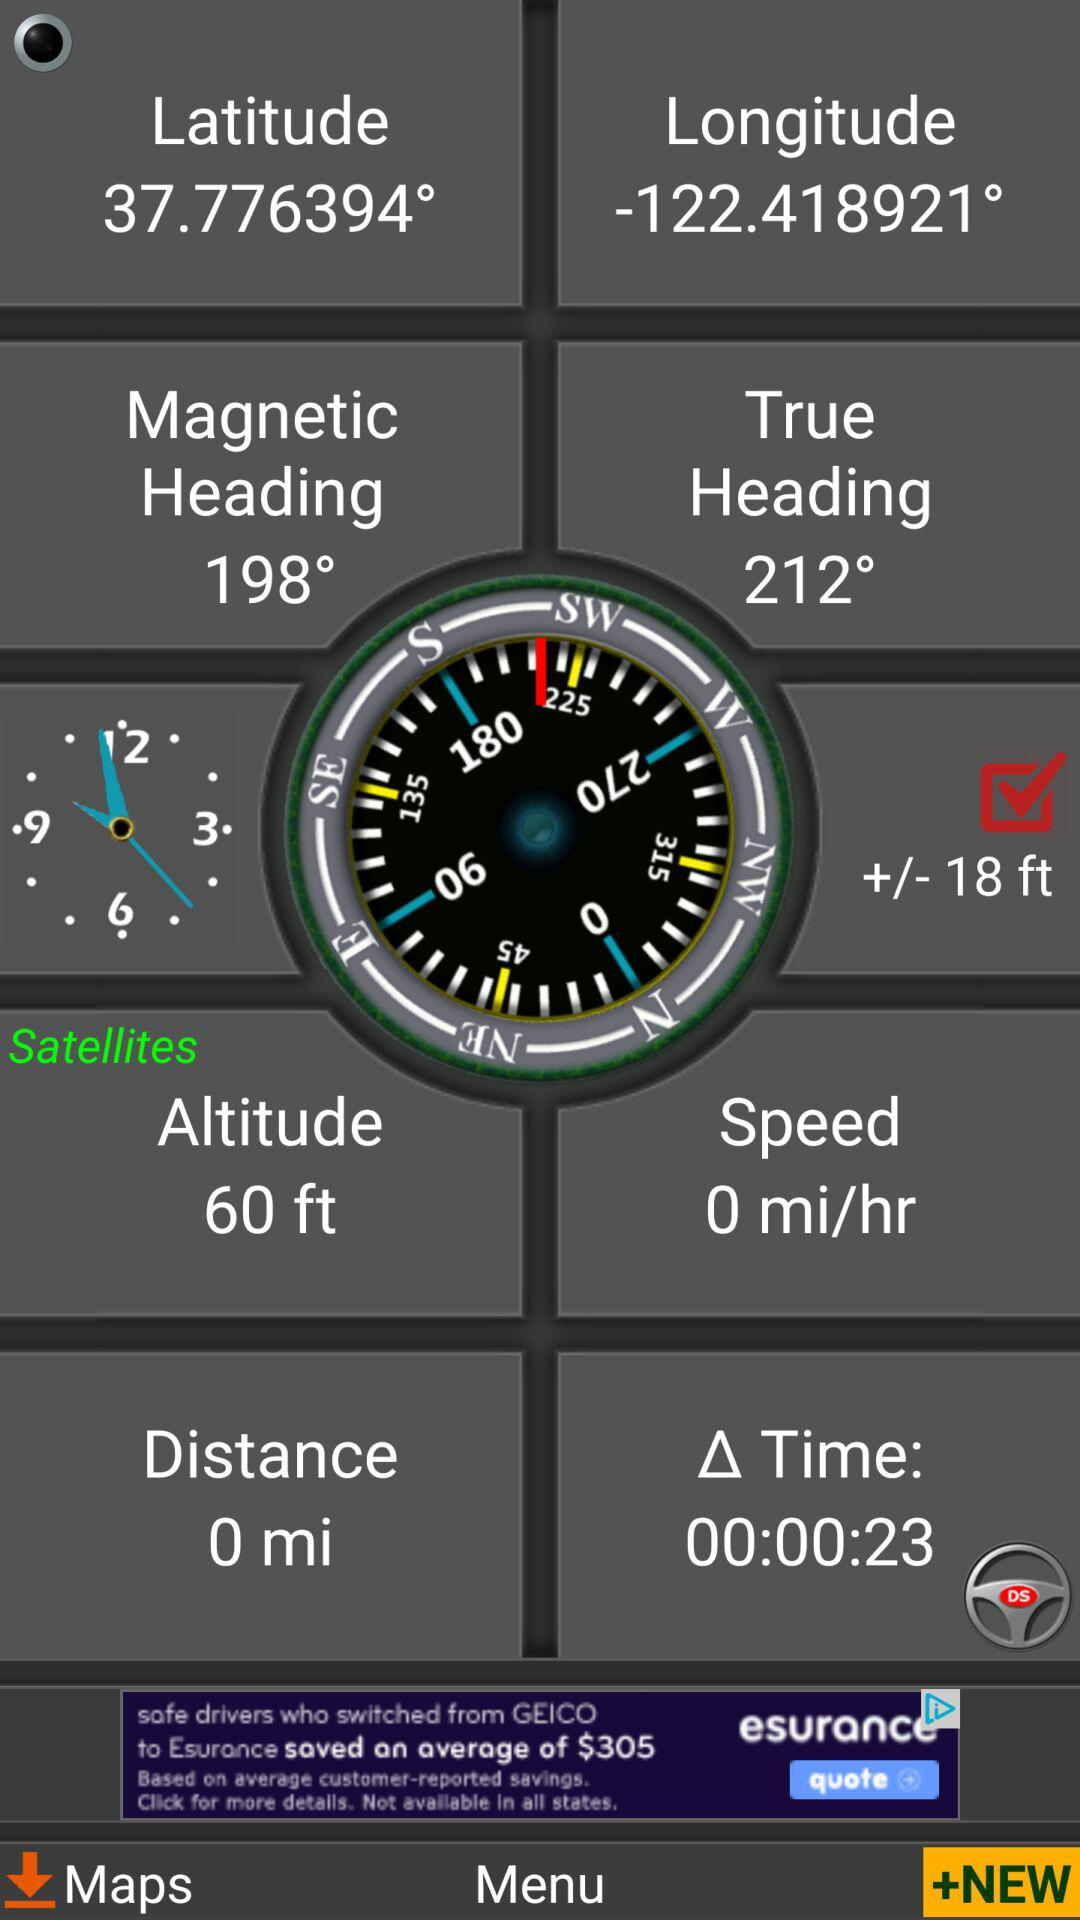How many minutes has elapsed since the last location was updated?
Answer the question using a single word or phrase. 00:00:23 